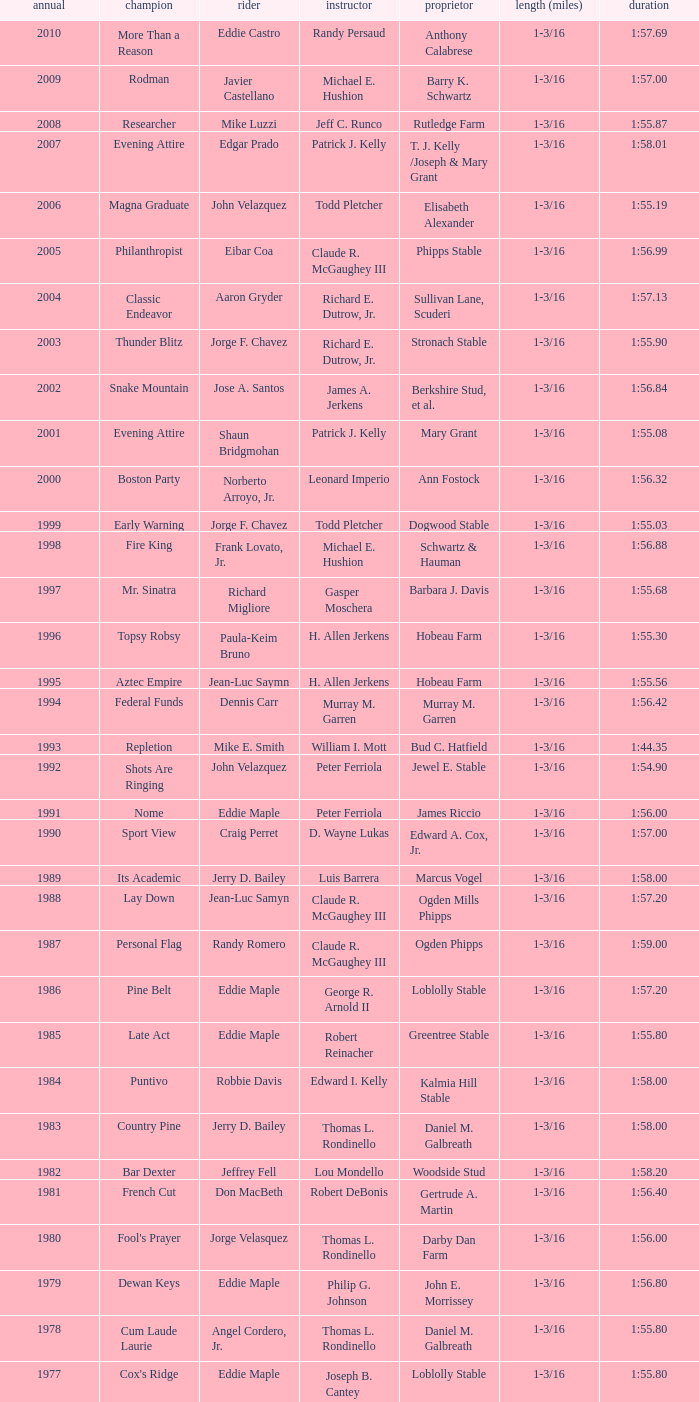Who was the jockey for the winning horse Helioptic? Paul Miller. 